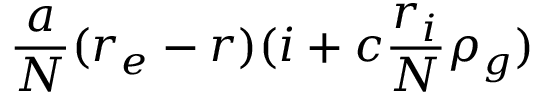Convert formula to latex. <formula><loc_0><loc_0><loc_500><loc_500>\frac { a } { N } ( r _ { e } - r ) ( i + c \frac { r _ { i } } { N } \rho _ { g } )</formula> 